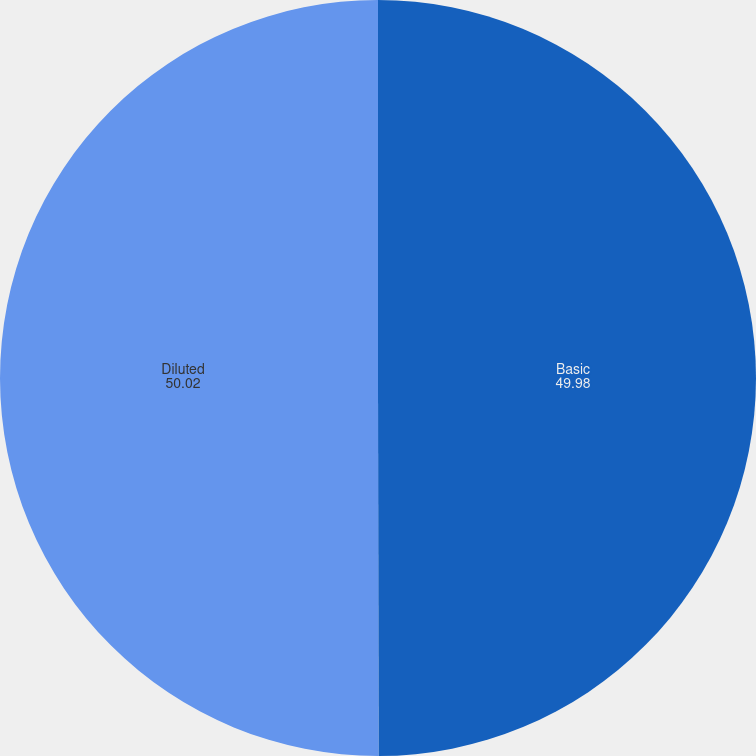<chart> <loc_0><loc_0><loc_500><loc_500><pie_chart><fcel>Basic<fcel>Diluted<nl><fcel>49.98%<fcel>50.02%<nl></chart> 